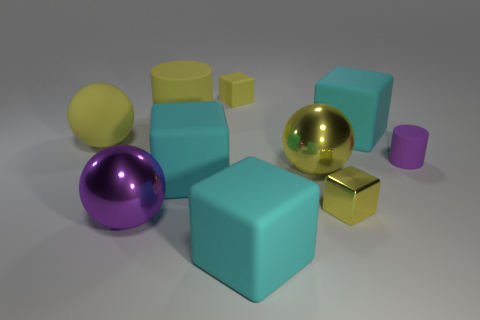Subtract all red balls. How many cyan blocks are left? 3 Subtract all yellow cubes. How many cubes are left? 3 Subtract all shiny balls. How many balls are left? 1 Subtract all brown blocks. Subtract all cyan cylinders. How many blocks are left? 5 Subtract all balls. How many objects are left? 7 Subtract 0 blue cylinders. How many objects are left? 10 Subtract all purple matte objects. Subtract all cyan matte cubes. How many objects are left? 6 Add 4 large rubber objects. How many large rubber objects are left? 9 Add 7 big cyan blocks. How many big cyan blocks exist? 10 